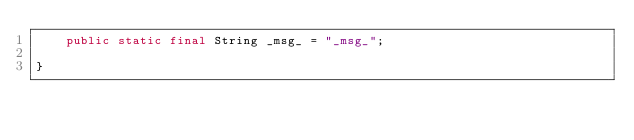<code> <loc_0><loc_0><loc_500><loc_500><_Java_>	public static final String _msg_ = "_msg_";

}
</code> 